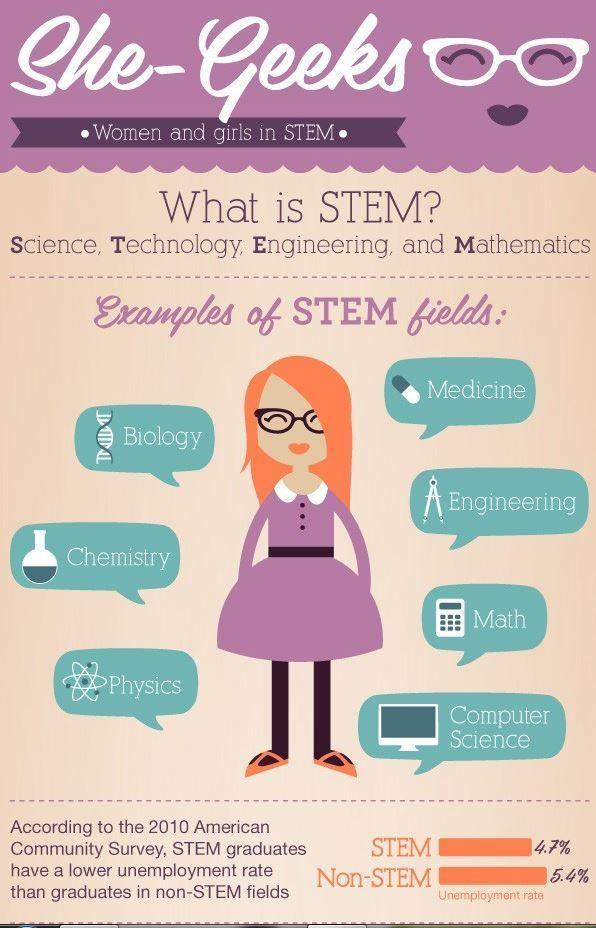Specify some key components in this picture. The unemployment rate among stem graduates, as reported by the 2010 American Community Survey, was 4.7%. 